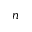<formula> <loc_0><loc_0><loc_500><loc_500>^ { n }</formula> 